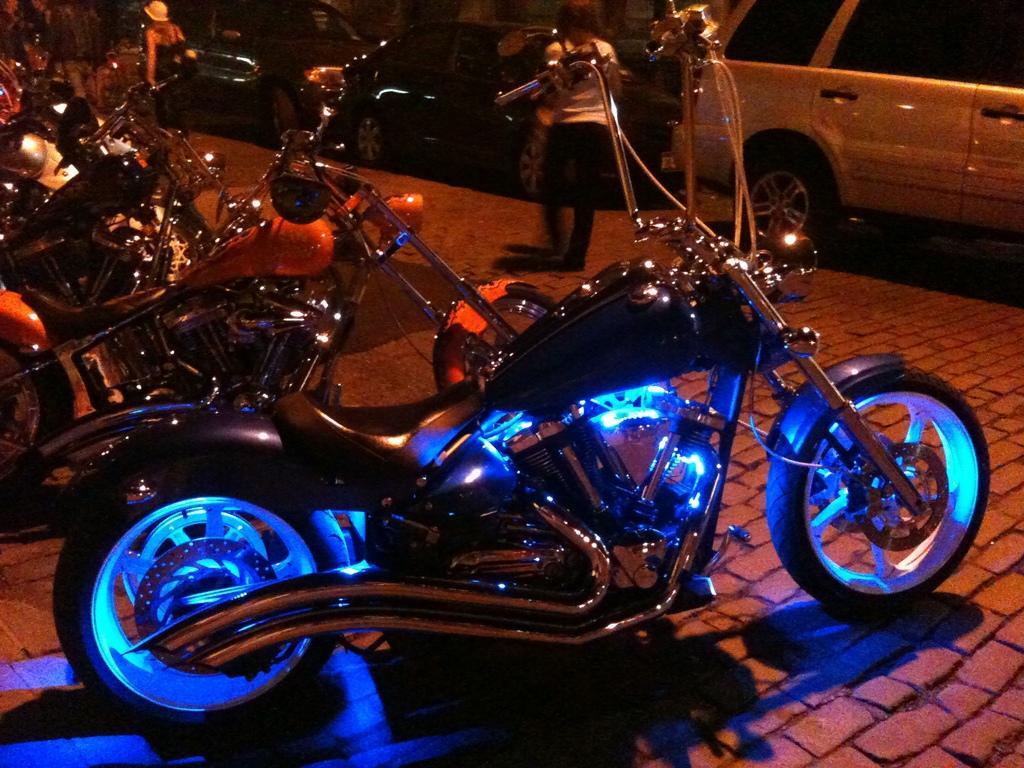Could you give a brief overview of what you see in this image? In this picture there are bikes in the center of the image and there are people and cars in the background area. 